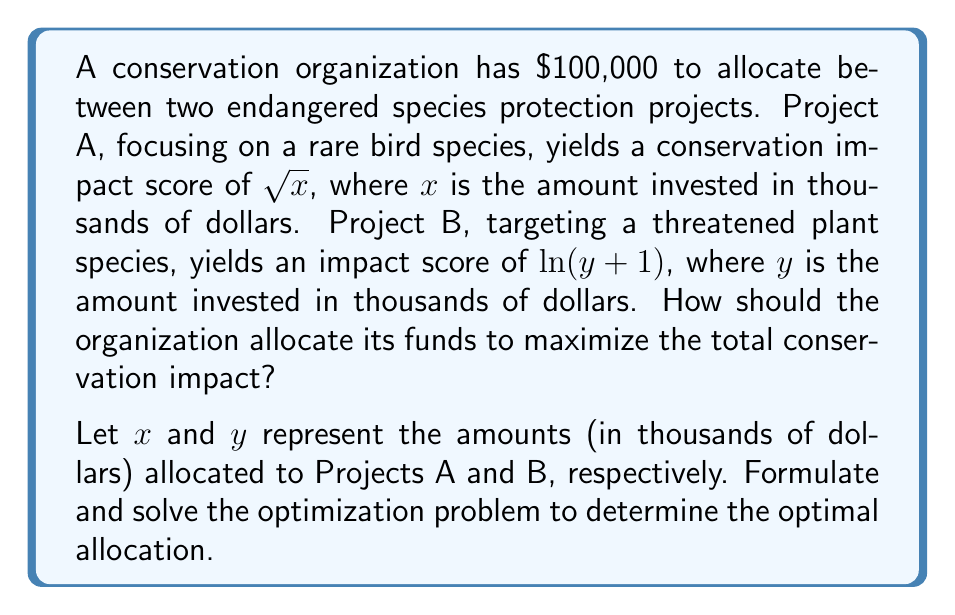Help me with this question. To solve this problem, we need to formulate and solve an optimization problem. Let's approach this step-by-step:

1) The objective function to maximize is the total conservation impact:
   $$f(x,y) = \sqrt{x} + \ln(y+1)$$

2) The constraint is the total budget:
   $$x + y = 100$$

3) We also have non-negativity constraints:
   $$x \geq 0, y \geq 0$$

4) To solve this constrained optimization problem, we can use the method of Lagrange multipliers. The Lagrangian function is:
   $$L(x,y,\lambda) = \sqrt{x} + \ln(y+1) + \lambda(100 - x - y)$$

5) We then set the partial derivatives equal to zero:
   $$\frac{\partial L}{\partial x} = \frac{1}{2\sqrt{x}} - \lambda = 0$$
   $$\frac{\partial L}{\partial y} = \frac{1}{y+1} - \lambda = 0$$
   $$\frac{\partial L}{\partial \lambda} = 100 - x - y = 0$$

6) From the first two equations:
   $$\frac{1}{2\sqrt{x}} = \frac{1}{y+1}$$

7) This implies:
   $$y+1 = 2\sqrt{x}$$
   $$y = 2\sqrt{x} - 1$$

8) Substituting this into the budget constraint:
   $$x + (2\sqrt{x} - 1) = 100$$
   $$x + 2\sqrt{x} = 101$$

9) This is a quadratic equation in $\sqrt{x}$. Solving it:
   $$(\sqrt{x})^2 + 2\sqrt{x} - 101 = 0$$
   $$\sqrt{x} = \frac{-2 + \sqrt{4 + 4(101)}}{2} \approx 9.95$$

10) Therefore:
    $$x \approx 99$$
    $$y \approx 1$$

Thus, the optimal allocation is approximately $99,000 to Project A and $1,000 to Project B.
Answer: The optimal allocation is approximately $99,000 to Project A (rare bird species) and $1,000 to Project B (threatened plant species). 